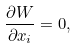<formula> <loc_0><loc_0><loc_500><loc_500>\frac { \partial W } { \partial x _ { i } } = 0 ,</formula> 